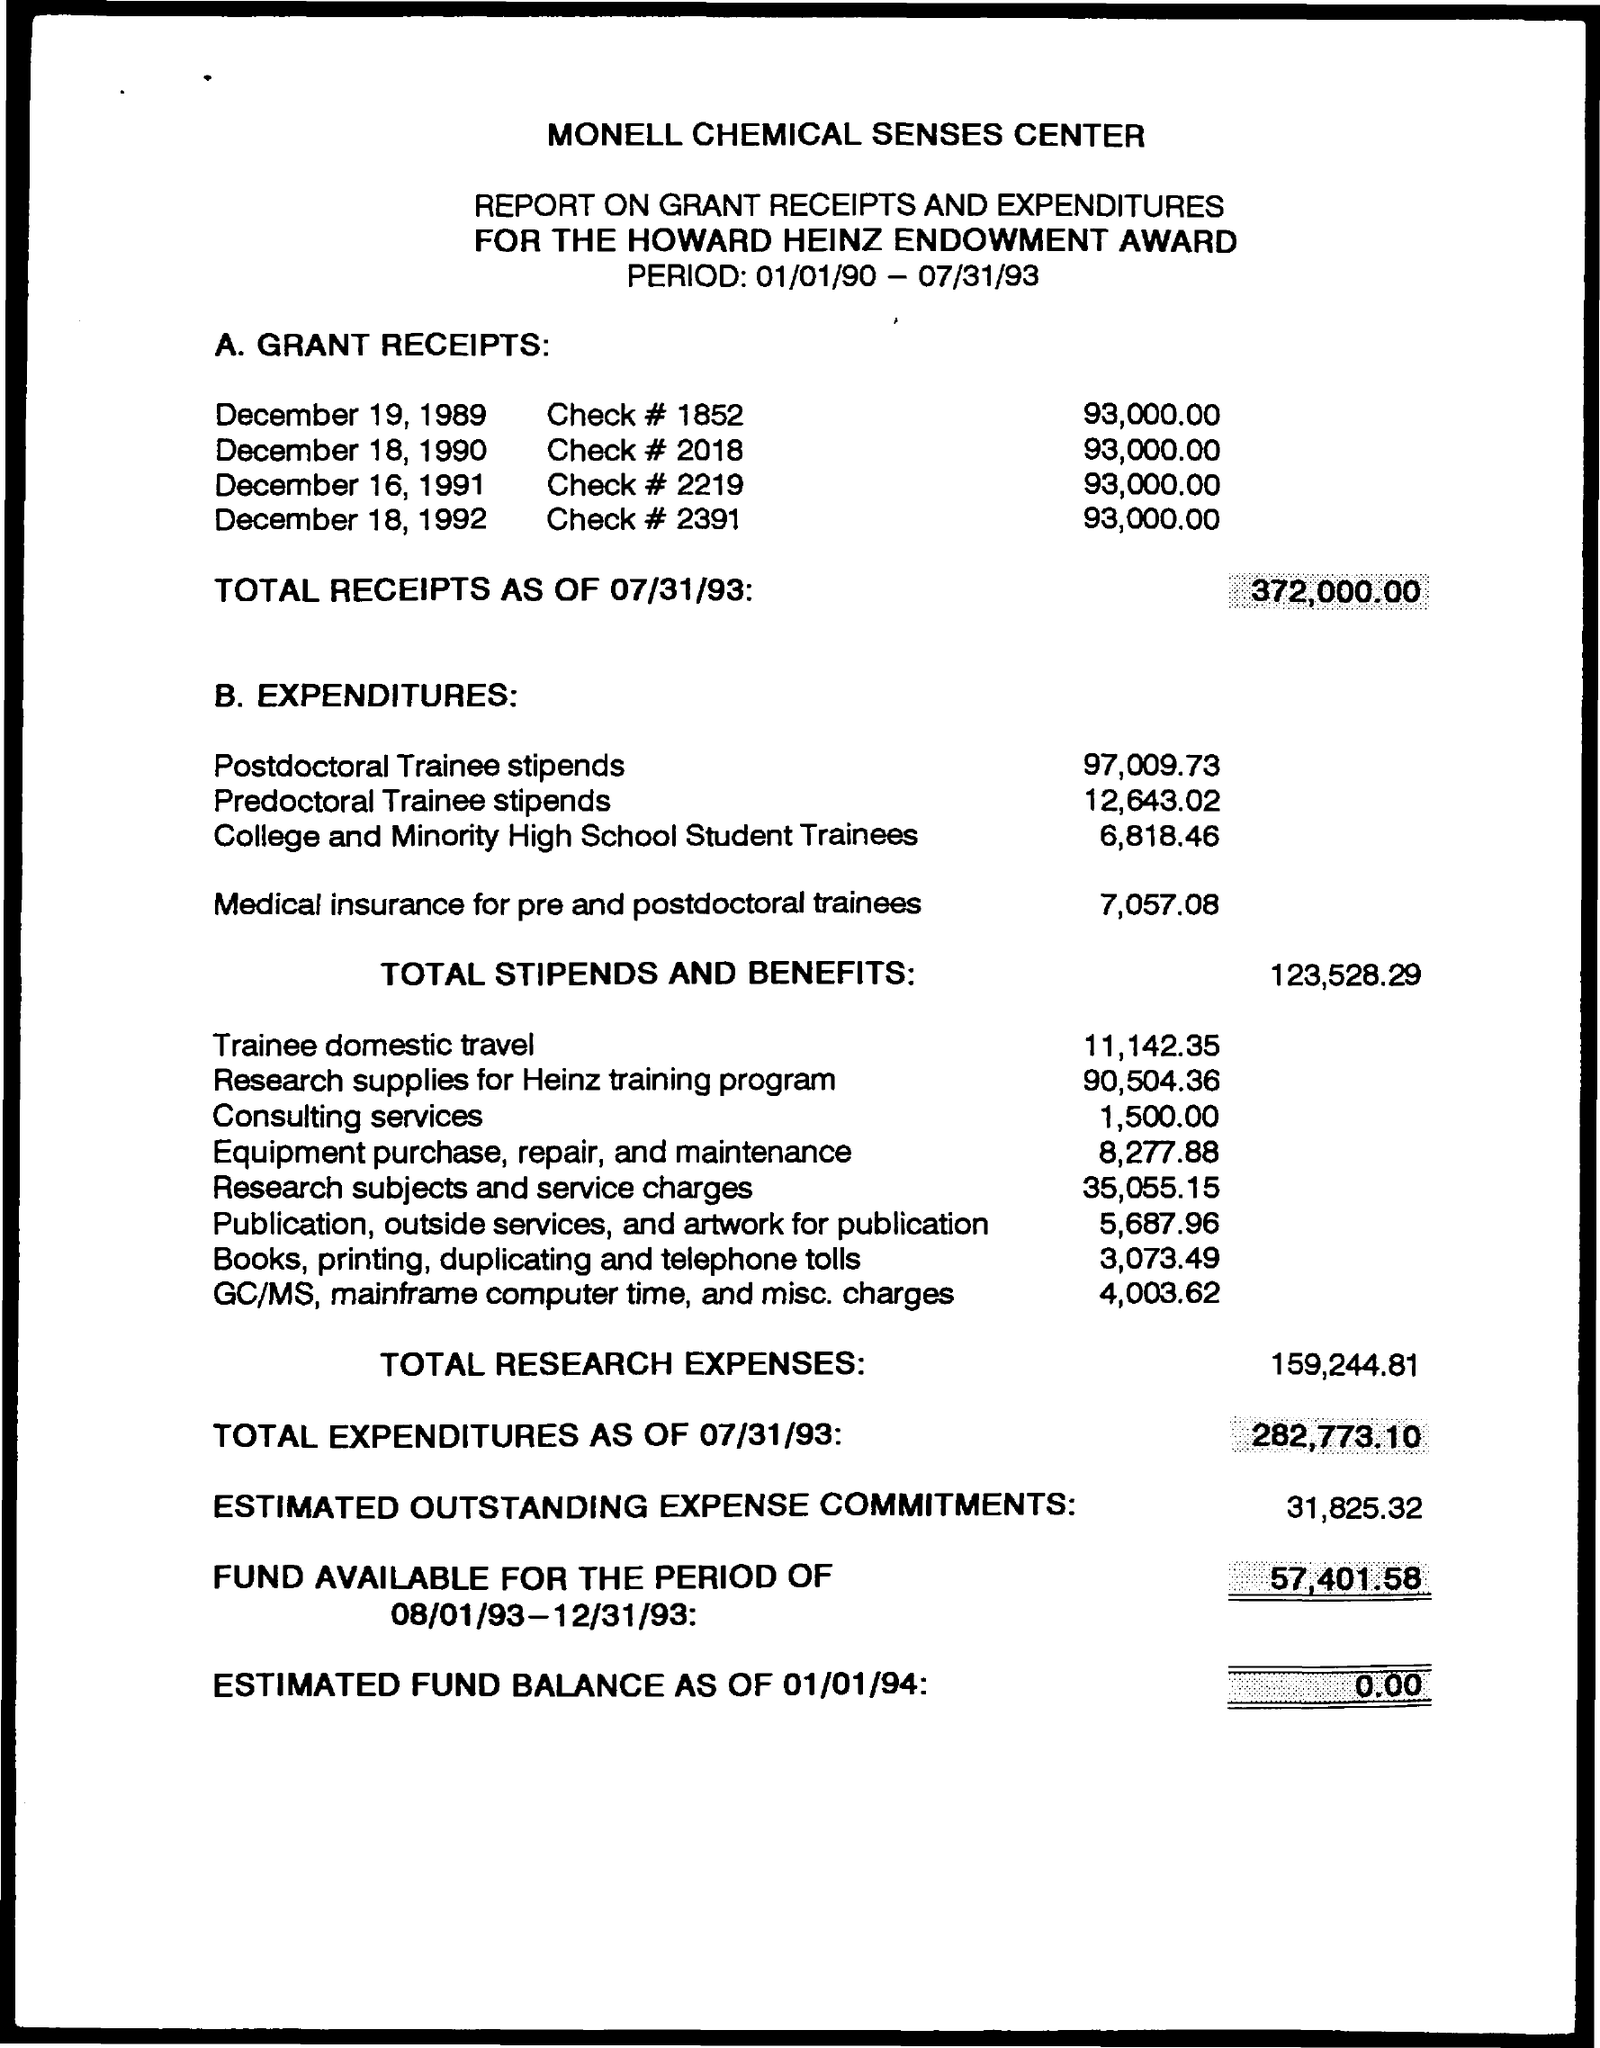Specify some key components in this picture. The total stipends and benefits amounted to 123,528.29. We incurred a total of 159,244.81 in research expenses. On December 19, 1989, the check number was 1852. The total receipts amount to 372,000.00. 